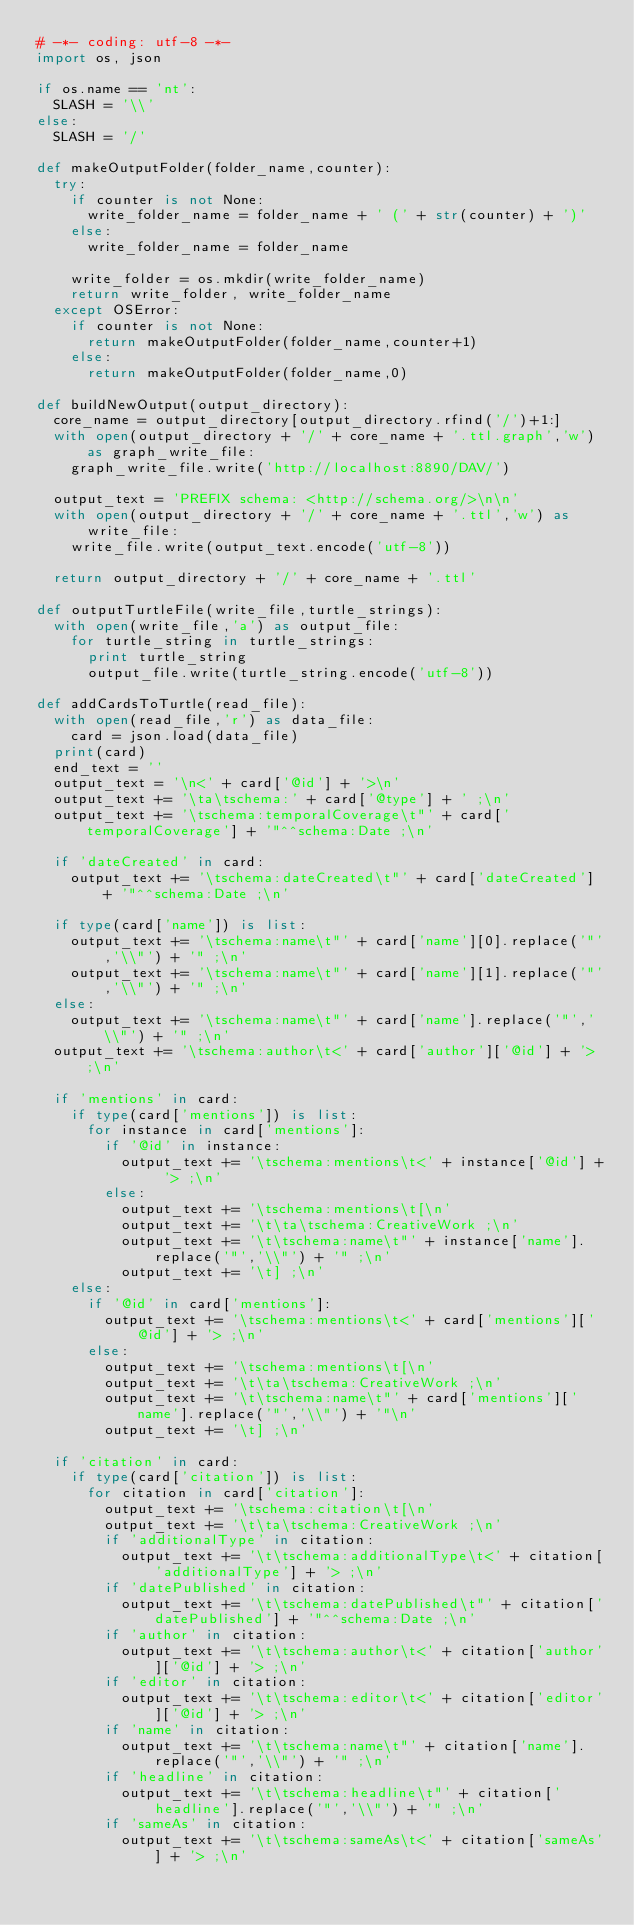Convert code to text. <code><loc_0><loc_0><loc_500><loc_500><_Python_># -*- coding: utf-8 -*-
import os, json

if os.name == 'nt':
	SLASH = '\\'
else:
	SLASH = '/'

def makeOutputFolder(folder_name,counter):
	try:
		if counter is not None:
			write_folder_name = folder_name + ' (' + str(counter) + ')'
		else:
			write_folder_name = folder_name

		write_folder = os.mkdir(write_folder_name)
		return write_folder, write_folder_name
	except OSError:
		if counter is not None:
			return makeOutputFolder(folder_name,counter+1)
		else:
			return makeOutputFolder(folder_name,0)

def buildNewOutput(output_directory):
	core_name = output_directory[output_directory.rfind('/')+1:]
	with open(output_directory + '/' + core_name + '.ttl.graph','w') as graph_write_file:
		graph_write_file.write('http://localhost:8890/DAV/')

	output_text = 'PREFIX schema: <http://schema.org/>\n\n'
	with open(output_directory + '/' + core_name + '.ttl','w') as write_file:
		write_file.write(output_text.encode('utf-8'))

	return output_directory + '/' + core_name + '.ttl'

def outputTurtleFile(write_file,turtle_strings):
	with open(write_file,'a') as output_file:
		for turtle_string in turtle_strings:
			print turtle_string
			output_file.write(turtle_string.encode('utf-8'))

def addCardsToTurtle(read_file):
	with open(read_file,'r') as data_file:
		card = json.load(data_file)
	print(card)
	end_text = ''
	output_text = '\n<' + card['@id'] + '>\n'
	output_text += '\ta\tschema:' + card['@type'] + ' ;\n'
	output_text += '\tschema:temporalCoverage\t"' + card['temporalCoverage'] + '"^^schema:Date ;\n'

	if 'dateCreated' in card:
		output_text += '\tschema:dateCreated\t"' + card['dateCreated'] + '"^^schema:Date ;\n'

	if type(card['name']) is list:
		output_text += '\tschema:name\t"' + card['name'][0].replace('"','\\"') + '" ;\n'
		output_text += '\tschema:name\t"' + card['name'][1].replace('"','\\"') + '" ;\n'
	else:
		output_text += '\tschema:name\t"' + card['name'].replace('"','\\"') + '" ;\n'
	output_text += '\tschema:author\t<' + card['author']['@id'] + '> ;\n'

	if 'mentions' in card:
		if type(card['mentions']) is list:
			for instance in card['mentions']:
				if '@id' in instance:
					output_text += '\tschema:mentions\t<' + instance['@id'] + '> ;\n'
				else:
					output_text += '\tschema:mentions\t[\n'
					output_text += '\t\ta\tschema:CreativeWork ;\n'
					output_text += '\t\tschema:name\t"' + instance['name'].replace('"','\\"') + '" ;\n'
					output_text += '\t] ;\n'
		else:
			if '@id' in card['mentions']:
				output_text += '\tschema:mentions\t<' + card['mentions']['@id'] + '> ;\n'
			else:
				output_text += '\tschema:mentions\t[\n'
				output_text += '\t\ta\tschema:CreativeWork ;\n'
				output_text += '\t\tschema:name\t"' + card['mentions']['name'].replace('"','\\"') + '"\n'
				output_text += '\t] ;\n'

	if 'citation' in card:
		if type(card['citation']) is list:
			for citation in card['citation']:
				output_text += '\tschema:citation\t[\n'
				output_text += '\t\ta\tschema:CreativeWork ;\n'
				if 'additionalType' in citation:
					output_text += '\t\tschema:additionalType\t<' + citation['additionalType'] + '> ;\n'
				if 'datePublished' in citation:
					output_text += '\t\tschema:datePublished\t"' + citation['datePublished'] + '"^^schema:Date ;\n'
				if 'author' in citation:
					output_text += '\t\tschema:author\t<' + citation['author']['@id'] + '> ;\n'
				if 'editor' in citation:
					output_text += '\t\tschema:editor\t<' + citation['editor']['@id'] + '> ;\n'
				if 'name' in citation:
					output_text += '\t\tschema:name\t"' + citation['name'].replace('"','\\"') + '" ;\n'
				if 'headline' in citation:
					output_text += '\t\tschema:headline\t"' + citation['headline'].replace('"','\\"') + '" ;\n'
				if 'sameAs' in citation:
					output_text += '\t\tschema:sameAs\t<' + citation['sameAs'] + '> ;\n'</code> 